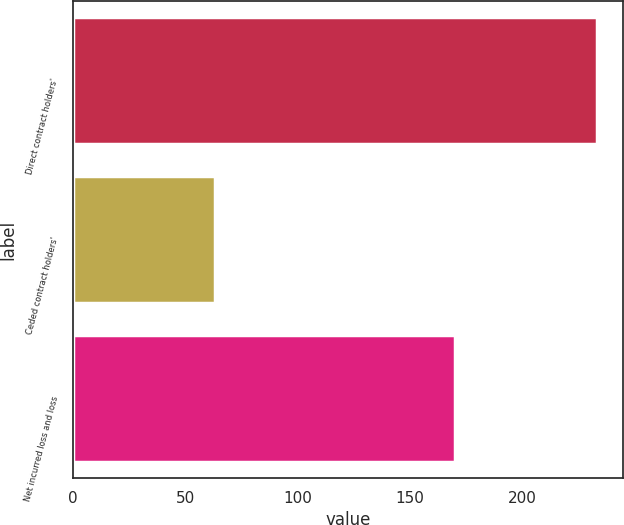Convert chart to OTSL. <chart><loc_0><loc_0><loc_500><loc_500><bar_chart><fcel>Direct contract holders'<fcel>Ceded contract holders'<fcel>Net incurred loss and loss<nl><fcel>233<fcel>63<fcel>170<nl></chart> 